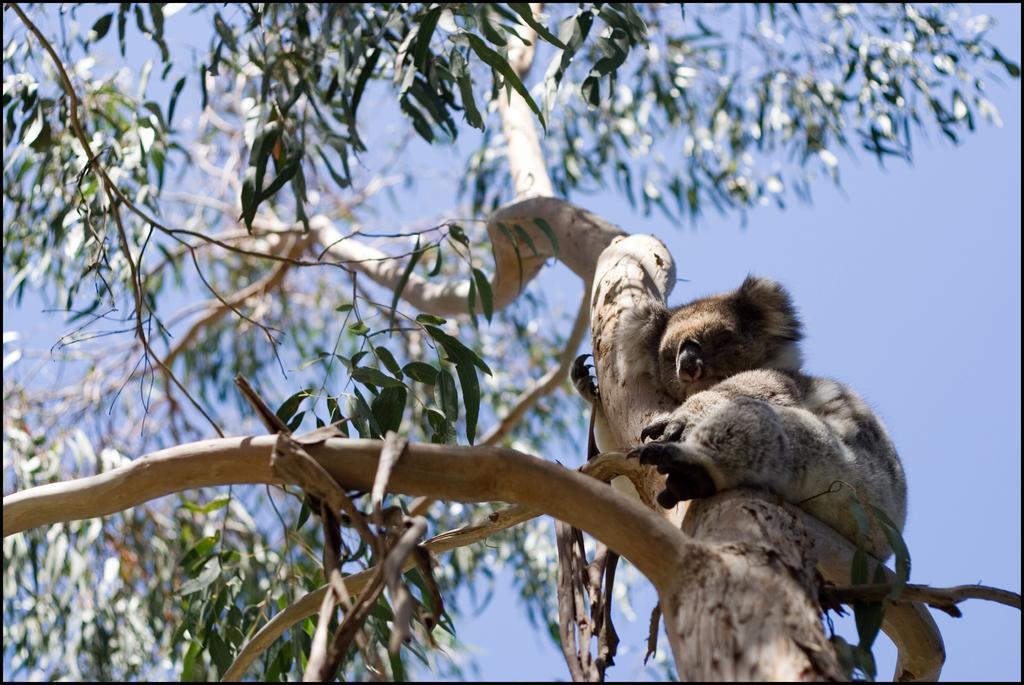Could you give a brief overview of what you see in this image? In this image we can see a koala bear on the tree. In the background there is a sky. 